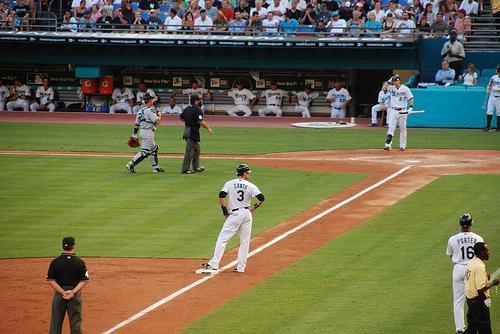How many catchers are there?
Give a very brief answer. 1. 